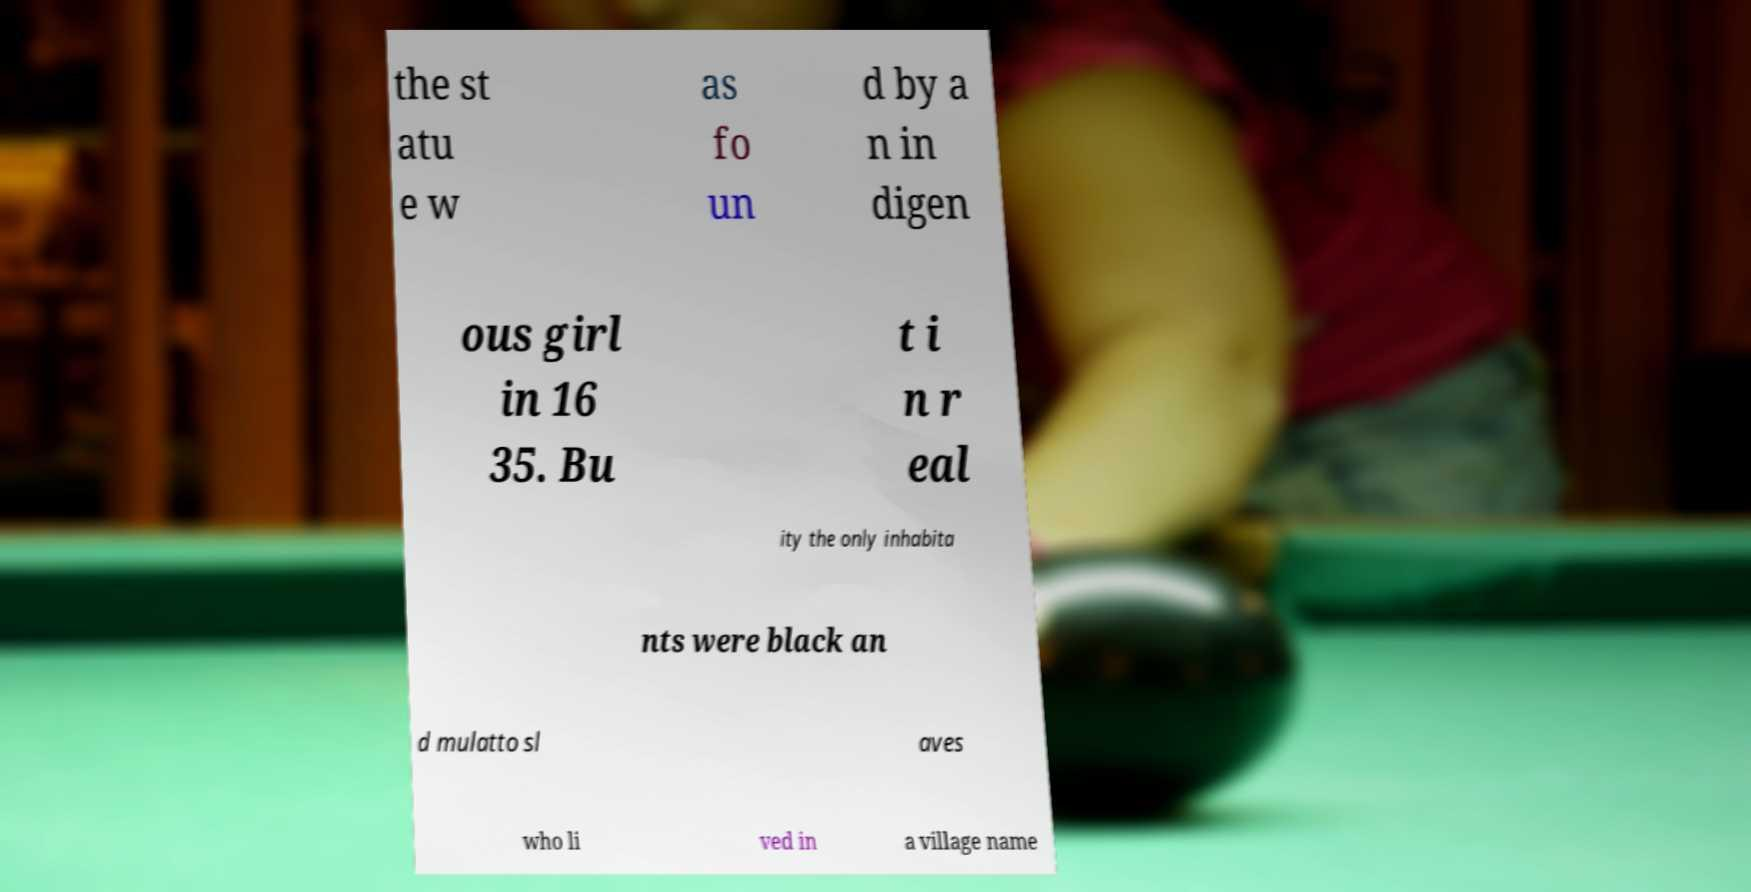I need the written content from this picture converted into text. Can you do that? the st atu e w as fo un d by a n in digen ous girl in 16 35. Bu t i n r eal ity the only inhabita nts were black an d mulatto sl aves who li ved in a village name 